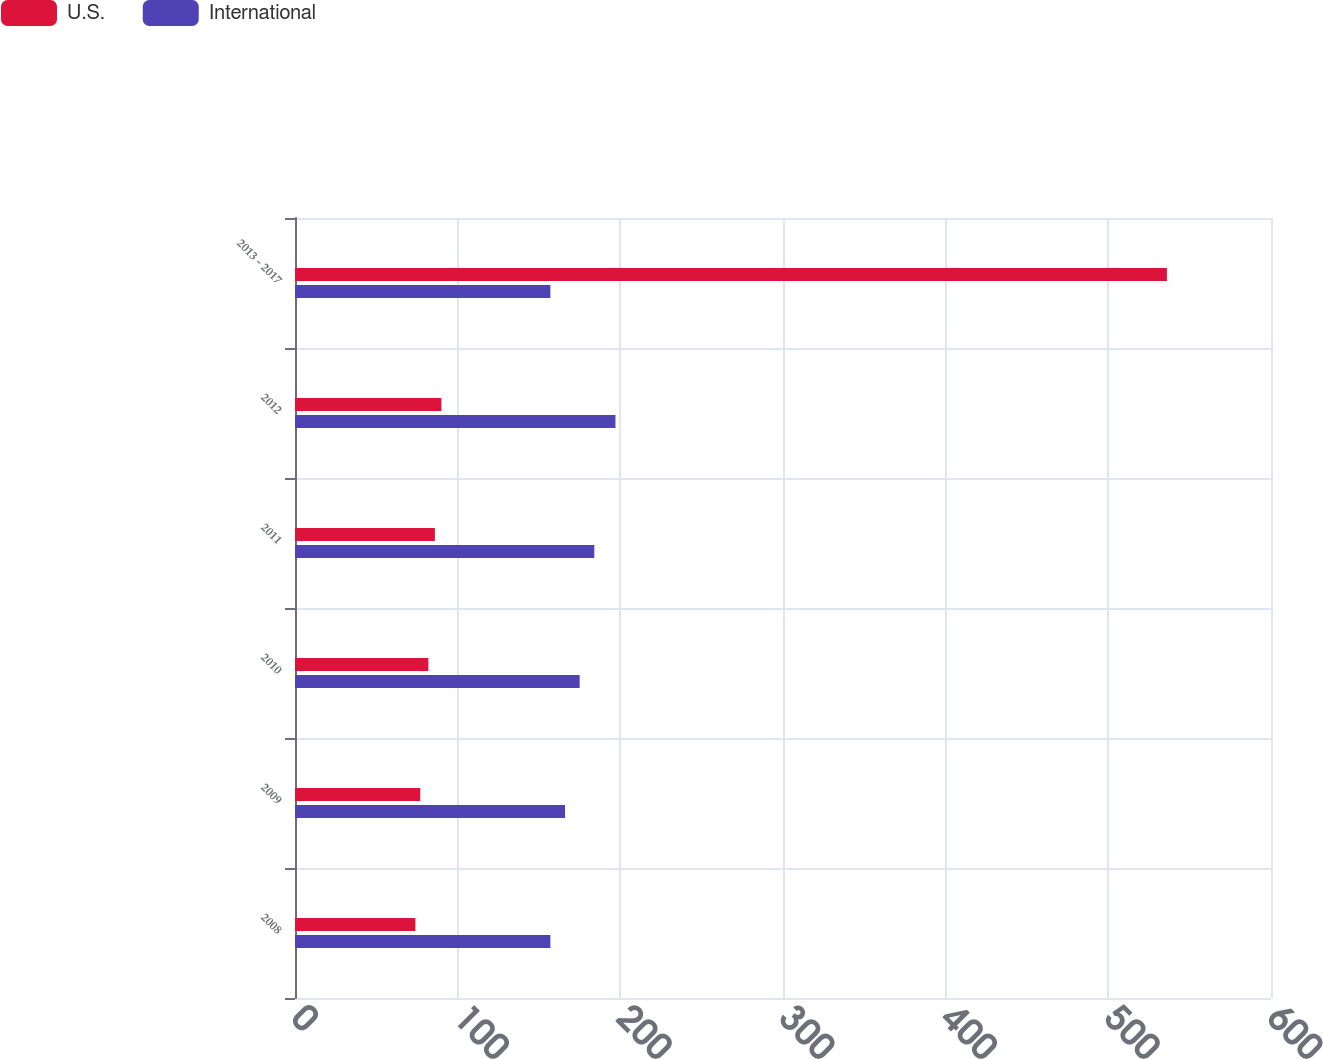<chart> <loc_0><loc_0><loc_500><loc_500><stacked_bar_chart><ecel><fcel>2008<fcel>2009<fcel>2010<fcel>2011<fcel>2012<fcel>2013 - 2017<nl><fcel>U.S.<fcel>74<fcel>77<fcel>82<fcel>86<fcel>90<fcel>536<nl><fcel>International<fcel>157<fcel>166<fcel>175<fcel>184<fcel>197<fcel>157<nl></chart> 